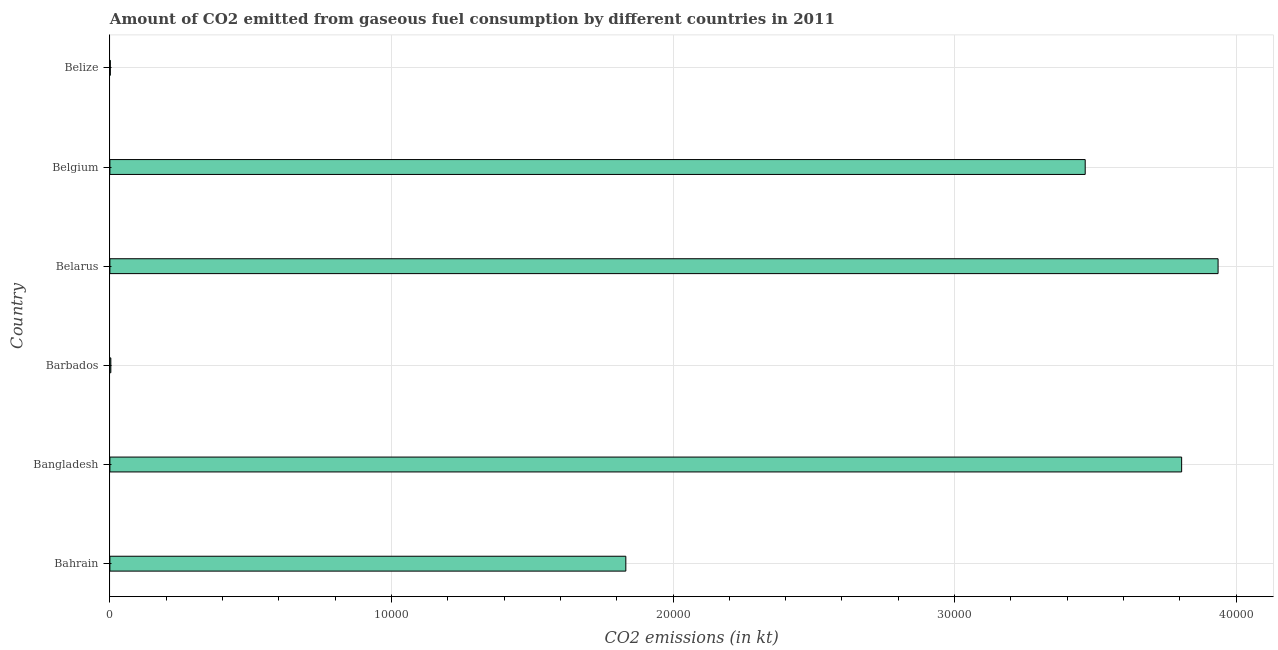Does the graph contain any zero values?
Give a very brief answer. No. What is the title of the graph?
Provide a short and direct response. Amount of CO2 emitted from gaseous fuel consumption by different countries in 2011. What is the label or title of the X-axis?
Keep it short and to the point. CO2 emissions (in kt). What is the co2 emissions from gaseous fuel consumption in Belgium?
Give a very brief answer. 3.46e+04. Across all countries, what is the maximum co2 emissions from gaseous fuel consumption?
Give a very brief answer. 3.94e+04. Across all countries, what is the minimum co2 emissions from gaseous fuel consumption?
Your answer should be very brief. 14.67. In which country was the co2 emissions from gaseous fuel consumption maximum?
Provide a short and direct response. Belarus. In which country was the co2 emissions from gaseous fuel consumption minimum?
Offer a very short reply. Belize. What is the sum of the co2 emissions from gaseous fuel consumption?
Your response must be concise. 1.30e+05. What is the difference between the co2 emissions from gaseous fuel consumption in Barbados and Belarus?
Ensure brevity in your answer.  -3.93e+04. What is the average co2 emissions from gaseous fuel consumption per country?
Give a very brief answer. 2.17e+04. What is the median co2 emissions from gaseous fuel consumption?
Keep it short and to the point. 2.65e+04. In how many countries, is the co2 emissions from gaseous fuel consumption greater than 6000 kt?
Your answer should be compact. 4. What is the ratio of the co2 emissions from gaseous fuel consumption in Bangladesh to that in Belarus?
Offer a very short reply. 0.97. Is the co2 emissions from gaseous fuel consumption in Belgium less than that in Belize?
Offer a terse response. No. Is the difference between the co2 emissions from gaseous fuel consumption in Bahrain and Bangladesh greater than the difference between any two countries?
Make the answer very short. No. What is the difference between the highest and the second highest co2 emissions from gaseous fuel consumption?
Your response must be concise. 1294.45. Is the sum of the co2 emissions from gaseous fuel consumption in Bangladesh and Belize greater than the maximum co2 emissions from gaseous fuel consumption across all countries?
Give a very brief answer. No. What is the difference between the highest and the lowest co2 emissions from gaseous fuel consumption?
Keep it short and to the point. 3.93e+04. In how many countries, is the co2 emissions from gaseous fuel consumption greater than the average co2 emissions from gaseous fuel consumption taken over all countries?
Ensure brevity in your answer.  3. What is the difference between two consecutive major ticks on the X-axis?
Offer a very short reply. 10000. What is the CO2 emissions (in kt) of Bahrain?
Provide a short and direct response. 1.83e+04. What is the CO2 emissions (in kt) in Bangladesh?
Keep it short and to the point. 3.81e+04. What is the CO2 emissions (in kt) of Barbados?
Make the answer very short. 33. What is the CO2 emissions (in kt) in Belarus?
Offer a very short reply. 3.94e+04. What is the CO2 emissions (in kt) of Belgium?
Provide a short and direct response. 3.46e+04. What is the CO2 emissions (in kt) in Belize?
Ensure brevity in your answer.  14.67. What is the difference between the CO2 emissions (in kt) in Bahrain and Bangladesh?
Keep it short and to the point. -1.97e+04. What is the difference between the CO2 emissions (in kt) in Bahrain and Barbados?
Keep it short and to the point. 1.83e+04. What is the difference between the CO2 emissions (in kt) in Bahrain and Belarus?
Provide a succinct answer. -2.10e+04. What is the difference between the CO2 emissions (in kt) in Bahrain and Belgium?
Keep it short and to the point. -1.63e+04. What is the difference between the CO2 emissions (in kt) in Bahrain and Belize?
Provide a short and direct response. 1.83e+04. What is the difference between the CO2 emissions (in kt) in Bangladesh and Barbados?
Make the answer very short. 3.80e+04. What is the difference between the CO2 emissions (in kt) in Bangladesh and Belarus?
Keep it short and to the point. -1294.45. What is the difference between the CO2 emissions (in kt) in Bangladesh and Belgium?
Provide a succinct answer. 3424.98. What is the difference between the CO2 emissions (in kt) in Bangladesh and Belize?
Ensure brevity in your answer.  3.80e+04. What is the difference between the CO2 emissions (in kt) in Barbados and Belarus?
Make the answer very short. -3.93e+04. What is the difference between the CO2 emissions (in kt) in Barbados and Belgium?
Your answer should be very brief. -3.46e+04. What is the difference between the CO2 emissions (in kt) in Barbados and Belize?
Make the answer very short. 18.34. What is the difference between the CO2 emissions (in kt) in Belarus and Belgium?
Keep it short and to the point. 4719.43. What is the difference between the CO2 emissions (in kt) in Belarus and Belize?
Give a very brief answer. 3.93e+04. What is the difference between the CO2 emissions (in kt) in Belgium and Belize?
Provide a succinct answer. 3.46e+04. What is the ratio of the CO2 emissions (in kt) in Bahrain to that in Bangladesh?
Make the answer very short. 0.48. What is the ratio of the CO2 emissions (in kt) in Bahrain to that in Barbados?
Offer a very short reply. 555.22. What is the ratio of the CO2 emissions (in kt) in Bahrain to that in Belarus?
Your answer should be compact. 0.47. What is the ratio of the CO2 emissions (in kt) in Bahrain to that in Belgium?
Provide a short and direct response. 0.53. What is the ratio of the CO2 emissions (in kt) in Bahrain to that in Belize?
Your answer should be compact. 1249.25. What is the ratio of the CO2 emissions (in kt) in Bangladesh to that in Barbados?
Provide a succinct answer. 1153.33. What is the ratio of the CO2 emissions (in kt) in Bangladesh to that in Belarus?
Offer a terse response. 0.97. What is the ratio of the CO2 emissions (in kt) in Bangladesh to that in Belgium?
Offer a terse response. 1.1. What is the ratio of the CO2 emissions (in kt) in Bangladesh to that in Belize?
Provide a succinct answer. 2595. What is the ratio of the CO2 emissions (in kt) in Barbados to that in Belize?
Keep it short and to the point. 2.25. What is the ratio of the CO2 emissions (in kt) in Belarus to that in Belgium?
Your response must be concise. 1.14. What is the ratio of the CO2 emissions (in kt) in Belarus to that in Belize?
Provide a succinct answer. 2683.25. What is the ratio of the CO2 emissions (in kt) in Belgium to that in Belize?
Provide a short and direct response. 2361.5. 